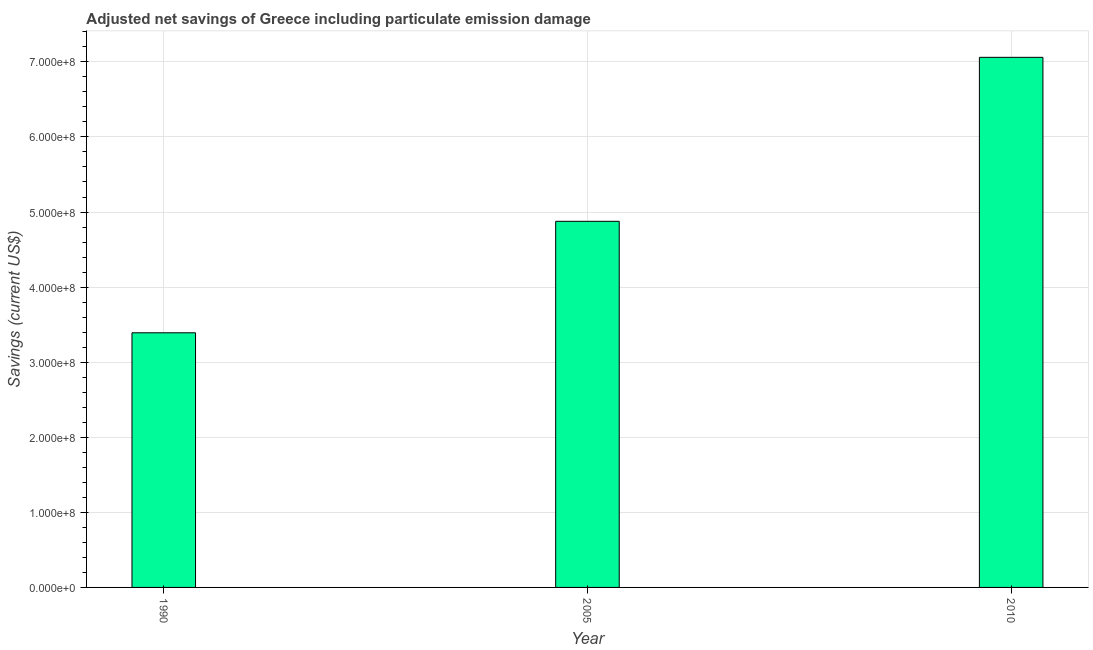Does the graph contain any zero values?
Offer a terse response. No. What is the title of the graph?
Your answer should be compact. Adjusted net savings of Greece including particulate emission damage. What is the label or title of the Y-axis?
Your answer should be very brief. Savings (current US$). What is the adjusted net savings in 1990?
Your response must be concise. 3.39e+08. Across all years, what is the maximum adjusted net savings?
Provide a succinct answer. 7.06e+08. Across all years, what is the minimum adjusted net savings?
Your response must be concise. 3.39e+08. What is the sum of the adjusted net savings?
Give a very brief answer. 1.53e+09. What is the difference between the adjusted net savings in 1990 and 2005?
Provide a short and direct response. -1.48e+08. What is the average adjusted net savings per year?
Give a very brief answer. 5.11e+08. What is the median adjusted net savings?
Give a very brief answer. 4.88e+08. In how many years, is the adjusted net savings greater than 120000000 US$?
Give a very brief answer. 3. What is the ratio of the adjusted net savings in 2005 to that in 2010?
Give a very brief answer. 0.69. What is the difference between the highest and the second highest adjusted net savings?
Your response must be concise. 2.18e+08. What is the difference between the highest and the lowest adjusted net savings?
Your answer should be very brief. 3.67e+08. In how many years, is the adjusted net savings greater than the average adjusted net savings taken over all years?
Offer a very short reply. 1. What is the Savings (current US$) in 1990?
Give a very brief answer. 3.39e+08. What is the Savings (current US$) in 2005?
Your answer should be very brief. 4.88e+08. What is the Savings (current US$) in 2010?
Your response must be concise. 7.06e+08. What is the difference between the Savings (current US$) in 1990 and 2005?
Provide a short and direct response. -1.48e+08. What is the difference between the Savings (current US$) in 1990 and 2010?
Provide a short and direct response. -3.67e+08. What is the difference between the Savings (current US$) in 2005 and 2010?
Your response must be concise. -2.18e+08. What is the ratio of the Savings (current US$) in 1990 to that in 2005?
Ensure brevity in your answer.  0.7. What is the ratio of the Savings (current US$) in 1990 to that in 2010?
Offer a terse response. 0.48. What is the ratio of the Savings (current US$) in 2005 to that in 2010?
Offer a very short reply. 0.69. 